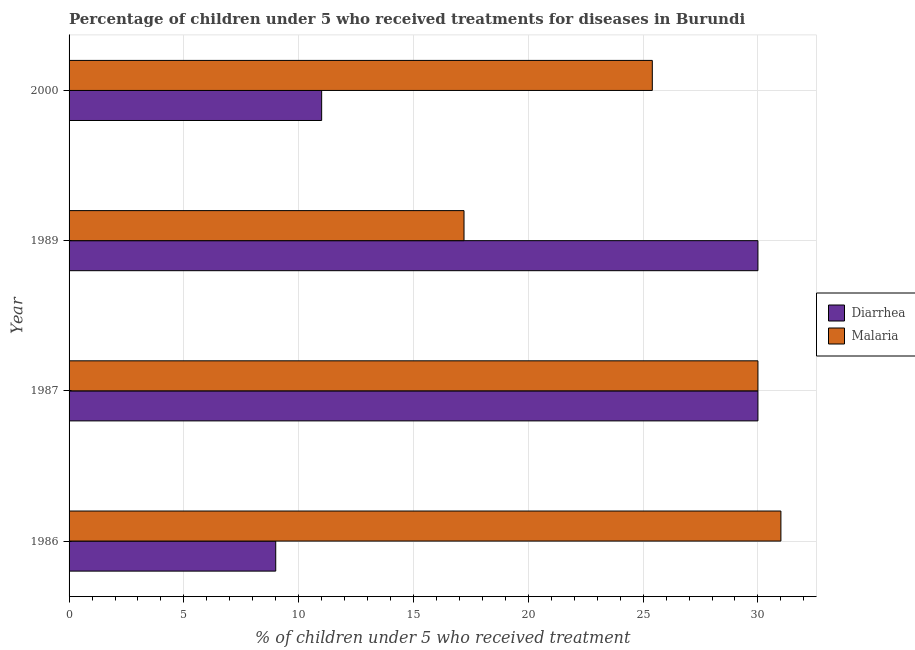Are the number of bars per tick equal to the number of legend labels?
Keep it short and to the point. Yes. Are the number of bars on each tick of the Y-axis equal?
Offer a very short reply. Yes. How many bars are there on the 1st tick from the top?
Give a very brief answer. 2. How many bars are there on the 4th tick from the bottom?
Keep it short and to the point. 2. What is the label of the 2nd group of bars from the top?
Provide a short and direct response. 1989. What is the percentage of children who received treatment for malaria in 1989?
Offer a very short reply. 17.2. Across all years, what is the maximum percentage of children who received treatment for diarrhoea?
Keep it short and to the point. 30. In which year was the percentage of children who received treatment for malaria maximum?
Keep it short and to the point. 1986. What is the total percentage of children who received treatment for diarrhoea in the graph?
Ensure brevity in your answer.  80. What is the difference between the percentage of children who received treatment for diarrhoea in 1986 and the percentage of children who received treatment for malaria in 2000?
Make the answer very short. -16.4. What is the average percentage of children who received treatment for diarrhoea per year?
Your response must be concise. 20. In the year 1987, what is the difference between the percentage of children who received treatment for malaria and percentage of children who received treatment for diarrhoea?
Make the answer very short. 0. In how many years, is the percentage of children who received treatment for malaria greater than 17 %?
Keep it short and to the point. 4. What is the ratio of the percentage of children who received treatment for diarrhoea in 1986 to that in 2000?
Your answer should be compact. 0.82. What is the difference between the highest and the second highest percentage of children who received treatment for malaria?
Provide a succinct answer. 1. What does the 2nd bar from the top in 1986 represents?
Provide a succinct answer. Diarrhea. What does the 1st bar from the bottom in 1986 represents?
Your answer should be compact. Diarrhea. How many bars are there?
Provide a short and direct response. 8. Does the graph contain any zero values?
Provide a succinct answer. No. How many legend labels are there?
Your response must be concise. 2. How are the legend labels stacked?
Your answer should be very brief. Vertical. What is the title of the graph?
Provide a succinct answer. Percentage of children under 5 who received treatments for diseases in Burundi. Does "International Tourists" appear as one of the legend labels in the graph?
Give a very brief answer. No. What is the label or title of the X-axis?
Make the answer very short. % of children under 5 who received treatment. What is the % of children under 5 who received treatment of Diarrhea in 1986?
Your response must be concise. 9. What is the % of children under 5 who received treatment of Malaria in 1986?
Provide a short and direct response. 31. What is the % of children under 5 who received treatment of Diarrhea in 1987?
Provide a short and direct response. 30. What is the % of children under 5 who received treatment of Diarrhea in 1989?
Offer a very short reply. 30. What is the % of children under 5 who received treatment in Diarrhea in 2000?
Provide a succinct answer. 11. What is the % of children under 5 who received treatment of Malaria in 2000?
Provide a succinct answer. 25.4. Across all years, what is the maximum % of children under 5 who received treatment in Diarrhea?
Provide a succinct answer. 30. Across all years, what is the maximum % of children under 5 who received treatment in Malaria?
Offer a terse response. 31. Across all years, what is the minimum % of children under 5 who received treatment of Diarrhea?
Provide a succinct answer. 9. Across all years, what is the minimum % of children under 5 who received treatment of Malaria?
Your answer should be compact. 17.2. What is the total % of children under 5 who received treatment in Malaria in the graph?
Make the answer very short. 103.6. What is the difference between the % of children under 5 who received treatment in Diarrhea in 1986 and that in 1987?
Your response must be concise. -21. What is the difference between the % of children under 5 who received treatment in Diarrhea in 1986 and that in 1989?
Your answer should be very brief. -21. What is the difference between the % of children under 5 who received treatment in Diarrhea in 1987 and that in 1989?
Your answer should be compact. 0. What is the difference between the % of children under 5 who received treatment in Malaria in 1987 and that in 2000?
Offer a terse response. 4.6. What is the difference between the % of children under 5 who received treatment in Diarrhea in 1986 and the % of children under 5 who received treatment in Malaria in 1987?
Keep it short and to the point. -21. What is the difference between the % of children under 5 who received treatment of Diarrhea in 1986 and the % of children under 5 who received treatment of Malaria in 1989?
Give a very brief answer. -8.2. What is the difference between the % of children under 5 who received treatment in Diarrhea in 1986 and the % of children under 5 who received treatment in Malaria in 2000?
Provide a succinct answer. -16.4. What is the difference between the % of children under 5 who received treatment in Diarrhea in 1987 and the % of children under 5 who received treatment in Malaria in 2000?
Make the answer very short. 4.6. What is the difference between the % of children under 5 who received treatment in Diarrhea in 1989 and the % of children under 5 who received treatment in Malaria in 2000?
Your answer should be very brief. 4.6. What is the average % of children under 5 who received treatment in Diarrhea per year?
Ensure brevity in your answer.  20. What is the average % of children under 5 who received treatment in Malaria per year?
Offer a very short reply. 25.9. In the year 1987, what is the difference between the % of children under 5 who received treatment of Diarrhea and % of children under 5 who received treatment of Malaria?
Provide a succinct answer. 0. In the year 1989, what is the difference between the % of children under 5 who received treatment of Diarrhea and % of children under 5 who received treatment of Malaria?
Keep it short and to the point. 12.8. In the year 2000, what is the difference between the % of children under 5 who received treatment of Diarrhea and % of children under 5 who received treatment of Malaria?
Your answer should be compact. -14.4. What is the ratio of the % of children under 5 who received treatment of Diarrhea in 1986 to that in 1987?
Your response must be concise. 0.3. What is the ratio of the % of children under 5 who received treatment in Diarrhea in 1986 to that in 1989?
Offer a terse response. 0.3. What is the ratio of the % of children under 5 who received treatment of Malaria in 1986 to that in 1989?
Offer a terse response. 1.8. What is the ratio of the % of children under 5 who received treatment of Diarrhea in 1986 to that in 2000?
Your answer should be very brief. 0.82. What is the ratio of the % of children under 5 who received treatment in Malaria in 1986 to that in 2000?
Your answer should be compact. 1.22. What is the ratio of the % of children under 5 who received treatment in Diarrhea in 1987 to that in 1989?
Offer a very short reply. 1. What is the ratio of the % of children under 5 who received treatment of Malaria in 1987 to that in 1989?
Give a very brief answer. 1.74. What is the ratio of the % of children under 5 who received treatment of Diarrhea in 1987 to that in 2000?
Offer a terse response. 2.73. What is the ratio of the % of children under 5 who received treatment in Malaria in 1987 to that in 2000?
Provide a short and direct response. 1.18. What is the ratio of the % of children under 5 who received treatment of Diarrhea in 1989 to that in 2000?
Ensure brevity in your answer.  2.73. What is the ratio of the % of children under 5 who received treatment in Malaria in 1989 to that in 2000?
Your answer should be very brief. 0.68. What is the difference between the highest and the second highest % of children under 5 who received treatment in Malaria?
Provide a succinct answer. 1. What is the difference between the highest and the lowest % of children under 5 who received treatment in Diarrhea?
Your response must be concise. 21. 